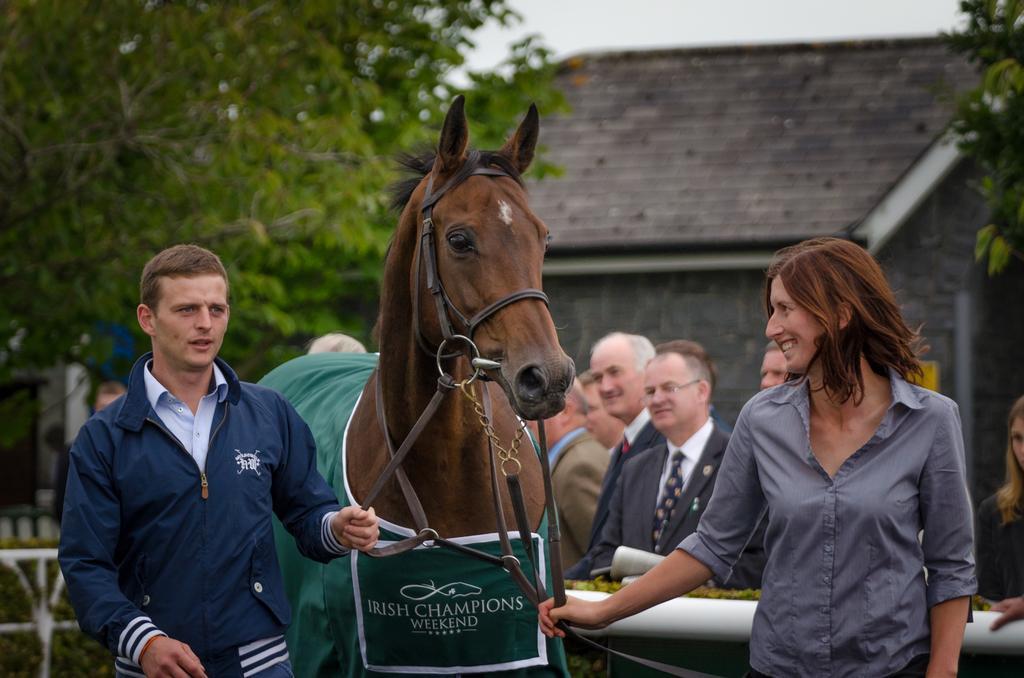Describe this image in one or two sentences. This is a picture taken in a stable or in a horse race. In the foreground of the picture there is a horse. On the right there is a man holding horse. On the left there is a woman, she is smiling. In the background of the center there are few people standing. In the top of the right there is a building and a tree. On the top left there are trees. 